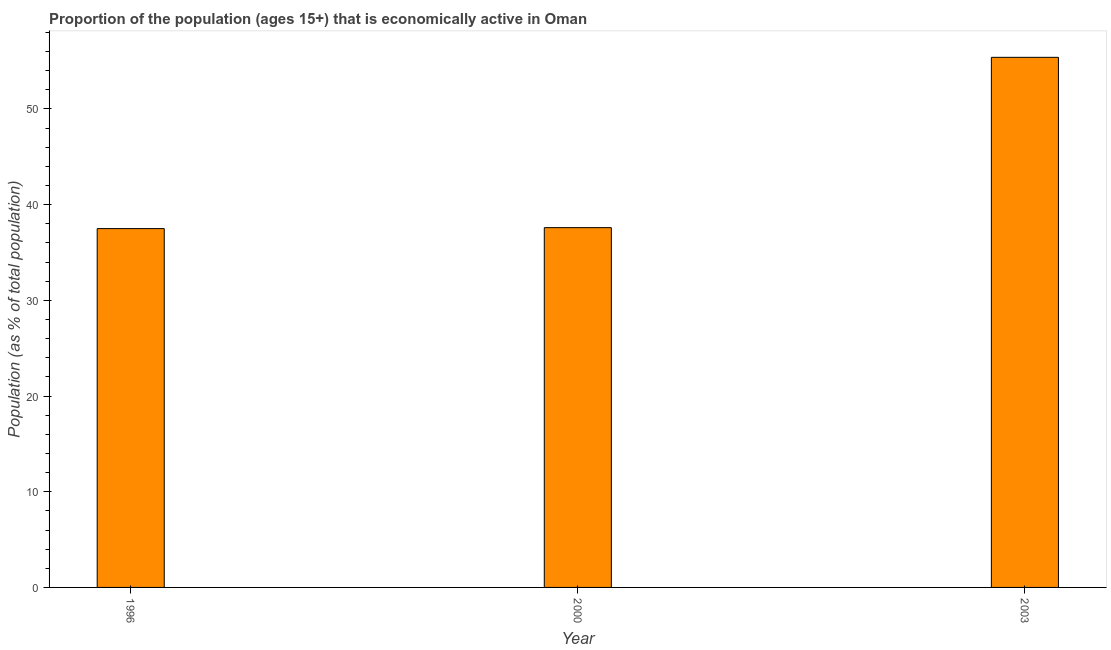Does the graph contain any zero values?
Make the answer very short. No. Does the graph contain grids?
Make the answer very short. No. What is the title of the graph?
Keep it short and to the point. Proportion of the population (ages 15+) that is economically active in Oman. What is the label or title of the Y-axis?
Provide a succinct answer. Population (as % of total population). What is the percentage of economically active population in 2000?
Your response must be concise. 37.6. Across all years, what is the maximum percentage of economically active population?
Offer a very short reply. 55.4. Across all years, what is the minimum percentage of economically active population?
Make the answer very short. 37.5. In which year was the percentage of economically active population maximum?
Make the answer very short. 2003. What is the sum of the percentage of economically active population?
Provide a short and direct response. 130.5. What is the difference between the percentage of economically active population in 1996 and 2003?
Provide a short and direct response. -17.9. What is the average percentage of economically active population per year?
Provide a succinct answer. 43.5. What is the median percentage of economically active population?
Your response must be concise. 37.6. What is the ratio of the percentage of economically active population in 1996 to that in 2003?
Ensure brevity in your answer.  0.68. Is the percentage of economically active population in 1996 less than that in 2000?
Make the answer very short. Yes. Is the sum of the percentage of economically active population in 1996 and 2003 greater than the maximum percentage of economically active population across all years?
Give a very brief answer. Yes. In how many years, is the percentage of economically active population greater than the average percentage of economically active population taken over all years?
Your answer should be very brief. 1. Are all the bars in the graph horizontal?
Your answer should be very brief. No. Are the values on the major ticks of Y-axis written in scientific E-notation?
Your answer should be compact. No. What is the Population (as % of total population) in 1996?
Offer a very short reply. 37.5. What is the Population (as % of total population) in 2000?
Your answer should be compact. 37.6. What is the Population (as % of total population) of 2003?
Ensure brevity in your answer.  55.4. What is the difference between the Population (as % of total population) in 1996 and 2000?
Make the answer very short. -0.1. What is the difference between the Population (as % of total population) in 1996 and 2003?
Your response must be concise. -17.9. What is the difference between the Population (as % of total population) in 2000 and 2003?
Give a very brief answer. -17.8. What is the ratio of the Population (as % of total population) in 1996 to that in 2003?
Your answer should be compact. 0.68. What is the ratio of the Population (as % of total population) in 2000 to that in 2003?
Make the answer very short. 0.68. 